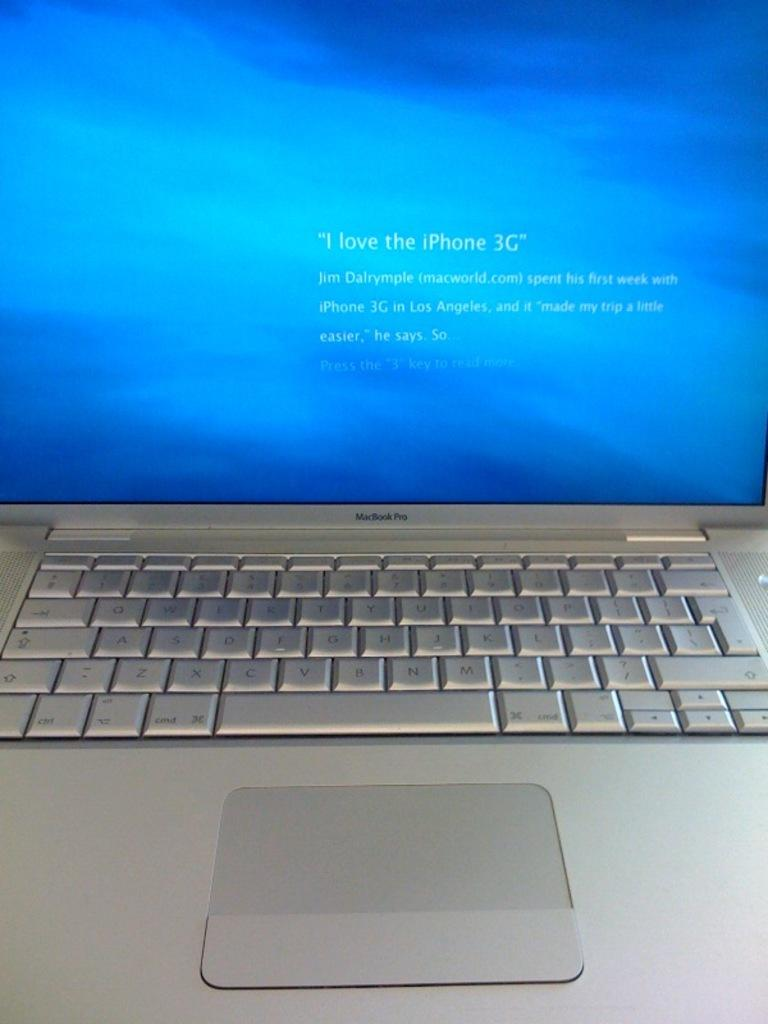<image>
Render a clear and concise summary of the photo. A computer screen that states to press the "3" to learn more about why Jim Dalrymple states "I love the Iphone 3G". 